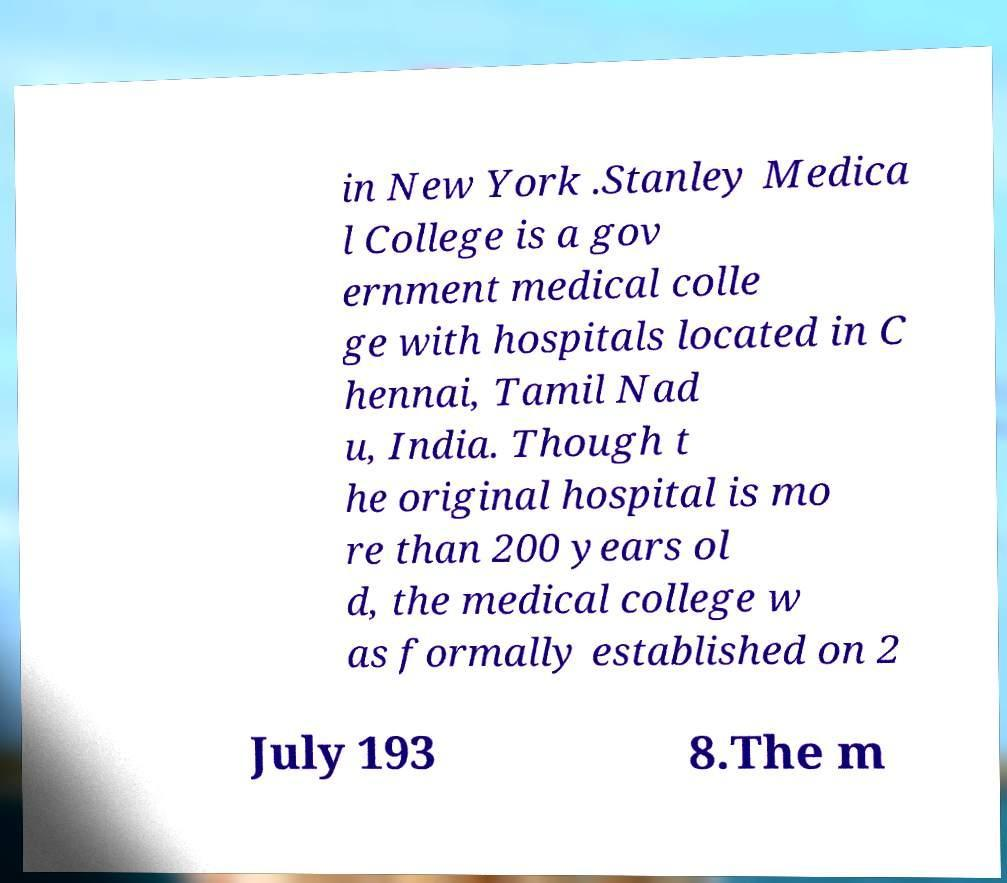I need the written content from this picture converted into text. Can you do that? in New York .Stanley Medica l College is a gov ernment medical colle ge with hospitals located in C hennai, Tamil Nad u, India. Though t he original hospital is mo re than 200 years ol d, the medical college w as formally established on 2 July 193 8.The m 